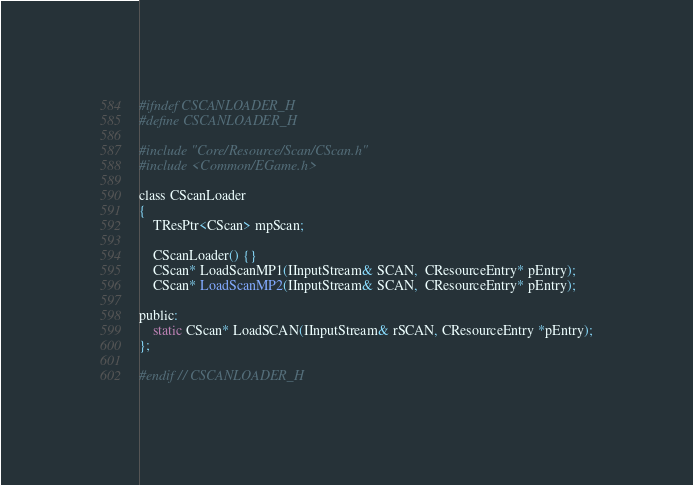Convert code to text. <code><loc_0><loc_0><loc_500><loc_500><_C_>#ifndef CSCANLOADER_H
#define CSCANLOADER_H

#include "Core/Resource/Scan/CScan.h"
#include <Common/EGame.h>

class CScanLoader
{
    TResPtr<CScan> mpScan;

    CScanLoader() {}
    CScan* LoadScanMP1(IInputStream& SCAN,  CResourceEntry* pEntry);
    CScan* LoadScanMP2(IInputStream& SCAN,  CResourceEntry* pEntry);

public:
    static CScan* LoadSCAN(IInputStream& rSCAN, CResourceEntry *pEntry);
};

#endif // CSCANLOADER_H
</code> 